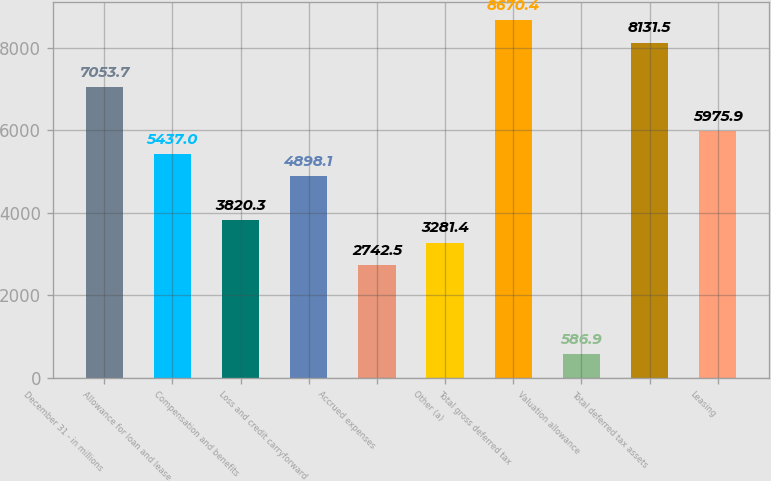Convert chart. <chart><loc_0><loc_0><loc_500><loc_500><bar_chart><fcel>December 31 - in millions<fcel>Allowance for loan and lease<fcel>Compensation and benefits<fcel>Loss and credit carryforward<fcel>Accrued expenses<fcel>Other (a)<fcel>Total gross deferred tax<fcel>Valuation allowance<fcel>Total deferred tax assets<fcel>Leasing<nl><fcel>7053.7<fcel>5437<fcel>3820.3<fcel>4898.1<fcel>2742.5<fcel>3281.4<fcel>8670.4<fcel>586.9<fcel>8131.5<fcel>5975.9<nl></chart> 